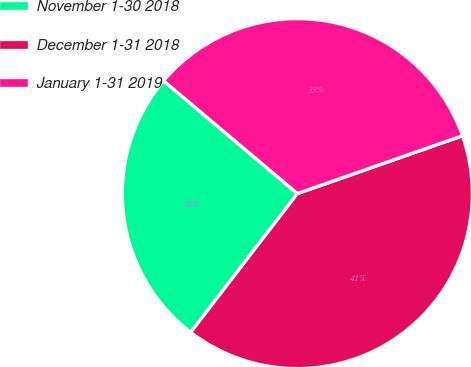Convert chart to OTSL. <chart><loc_0><loc_0><loc_500><loc_500><pie_chart><fcel>November 1-30 2018<fcel>December 1-31 2018<fcel>January 1-31 2019<nl><fcel>25.71%<fcel>40.8%<fcel>33.49%<nl></chart> 